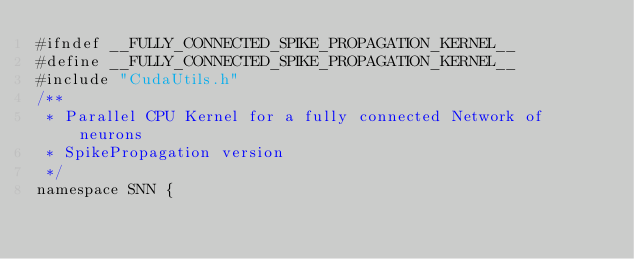<code> <loc_0><loc_0><loc_500><loc_500><_Cuda_>#ifndef __FULLY_CONNECTED_SPIKE_PROPAGATION_KERNEL__
#define __FULLY_CONNECTED_SPIKE_PROPAGATION_KERNEL__
#include "CudaUtils.h"
/**
 * Parallel CPU Kernel for a fully connected Network of neurons
 * SpikePropagation version
 */
namespace SNN {
</code> 